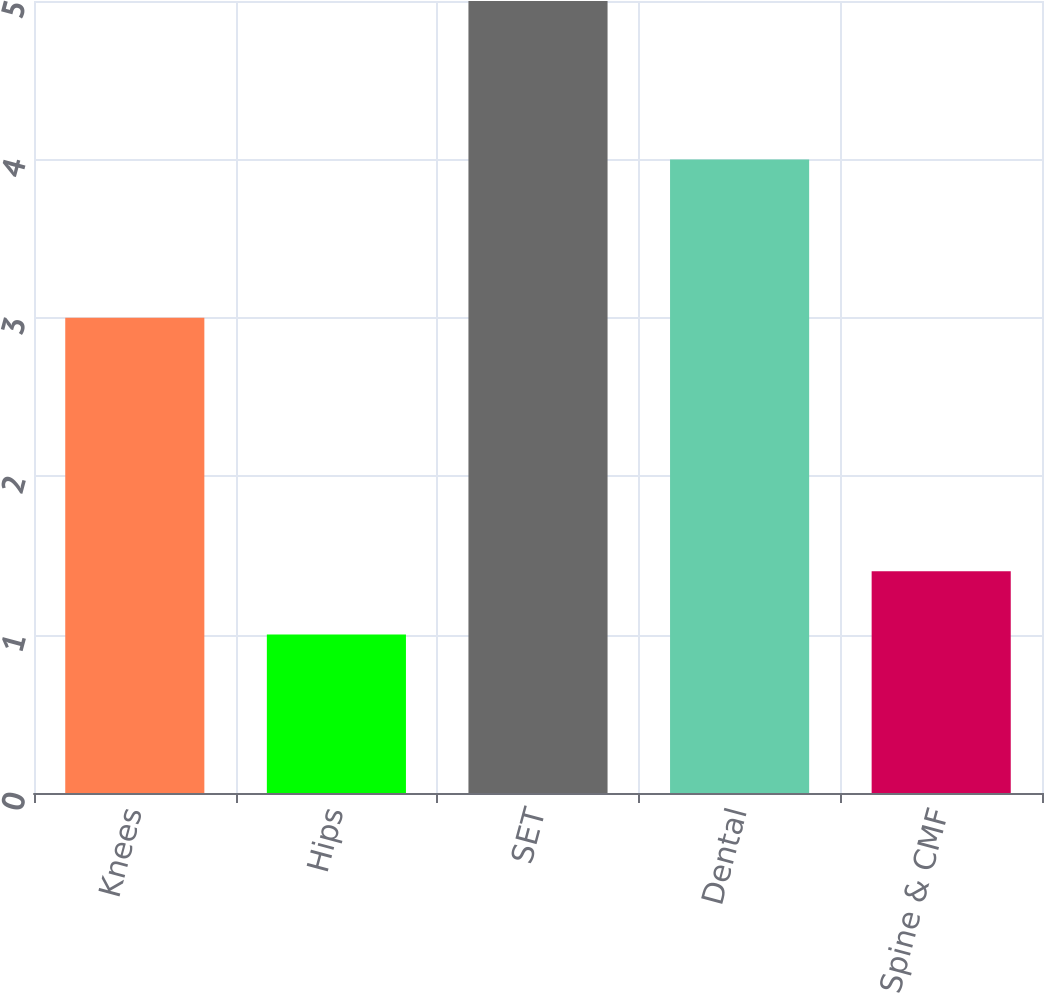Convert chart. <chart><loc_0><loc_0><loc_500><loc_500><bar_chart><fcel>Knees<fcel>Hips<fcel>SET<fcel>Dental<fcel>Spine & CMF<nl><fcel>3<fcel>1<fcel>5<fcel>4<fcel>1.4<nl></chart> 